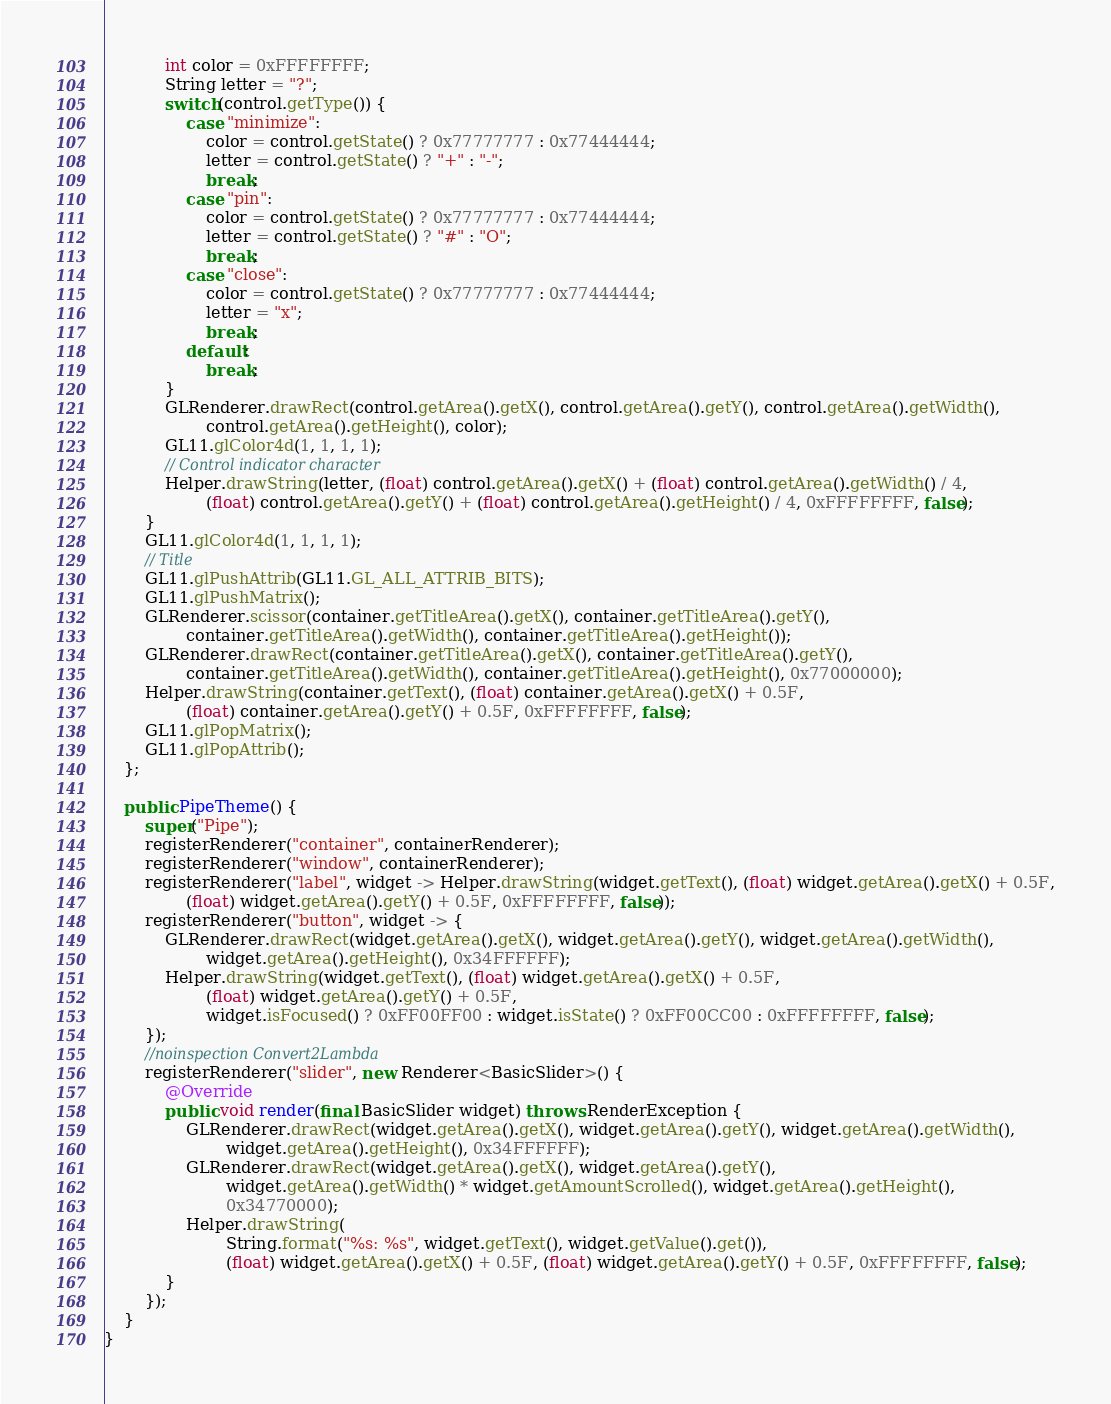Convert code to text. <code><loc_0><loc_0><loc_500><loc_500><_Java_>            int color = 0xFFFFFFFF;
            String letter = "?";
            switch(control.getType()) {
                case "minimize":
                    color = control.getState() ? 0x77777777 : 0x77444444;
                    letter = control.getState() ? "+" : "-";
                    break;
                case "pin":
                    color = control.getState() ? 0x77777777 : 0x77444444;
                    letter = control.getState() ? "#" : "O";
                    break;
                case "close":
                    color = control.getState() ? 0x77777777 : 0x77444444;
                    letter = "x";
                    break;
                default:
                    break;
            }
            GLRenderer.drawRect(control.getArea().getX(), control.getArea().getY(), control.getArea().getWidth(),
                    control.getArea().getHeight(), color);
            GL11.glColor4d(1, 1, 1, 1);
            // Control indicator character
            Helper.drawString(letter, (float) control.getArea().getX() + (float) control.getArea().getWidth() / 4,
                    (float) control.getArea().getY() + (float) control.getArea().getHeight() / 4, 0xFFFFFFFF, false);
        }
        GL11.glColor4d(1, 1, 1, 1);
        // Title
        GL11.glPushAttrib(GL11.GL_ALL_ATTRIB_BITS);
        GL11.glPushMatrix();
        GLRenderer.scissor(container.getTitleArea().getX(), container.getTitleArea().getY(),
                container.getTitleArea().getWidth(), container.getTitleArea().getHeight());
        GLRenderer.drawRect(container.getTitleArea().getX(), container.getTitleArea().getY(),
                container.getTitleArea().getWidth(), container.getTitleArea().getHeight(), 0x77000000);
        Helper.drawString(container.getText(), (float) container.getArea().getX() + 0.5F,
                (float) container.getArea().getY() + 0.5F, 0xFFFFFFFF, false);
        GL11.glPopMatrix();
        GL11.glPopAttrib();
    };

    public PipeTheme() {
        super("Pipe");
        registerRenderer("container", containerRenderer);
        registerRenderer("window", containerRenderer);
        registerRenderer("label", widget -> Helper.drawString(widget.getText(), (float) widget.getArea().getX() + 0.5F,
                (float) widget.getArea().getY() + 0.5F, 0xFFFFFFFF, false));
        registerRenderer("button", widget -> {
            GLRenderer.drawRect(widget.getArea().getX(), widget.getArea().getY(), widget.getArea().getWidth(),
                    widget.getArea().getHeight(), 0x34FFFFFF);
            Helper.drawString(widget.getText(), (float) widget.getArea().getX() + 0.5F,
                    (float) widget.getArea().getY() + 0.5F,
                    widget.isFocused() ? 0xFF00FF00 : widget.isState() ? 0xFF00CC00 : 0xFFFFFFFF, false);
        });
        //noinspection Convert2Lambda
        registerRenderer("slider", new Renderer<BasicSlider>() {
            @Override
            public void render(final BasicSlider widget) throws RenderException {
                GLRenderer.drawRect(widget.getArea().getX(), widget.getArea().getY(), widget.getArea().getWidth(),
                        widget.getArea().getHeight(), 0x34FFFFFF);
                GLRenderer.drawRect(widget.getArea().getX(), widget.getArea().getY(),
                        widget.getArea().getWidth() * widget.getAmountScrolled(), widget.getArea().getHeight(),
                        0x34770000);
                Helper.drawString(
                        String.format("%s: %s", widget.getText(), widget.getValue().get()),
                        (float) widget.getArea().getX() + 0.5F, (float) widget.getArea().getY() + 0.5F, 0xFFFFFFFF, false);
            }
        });
    }
}
</code> 